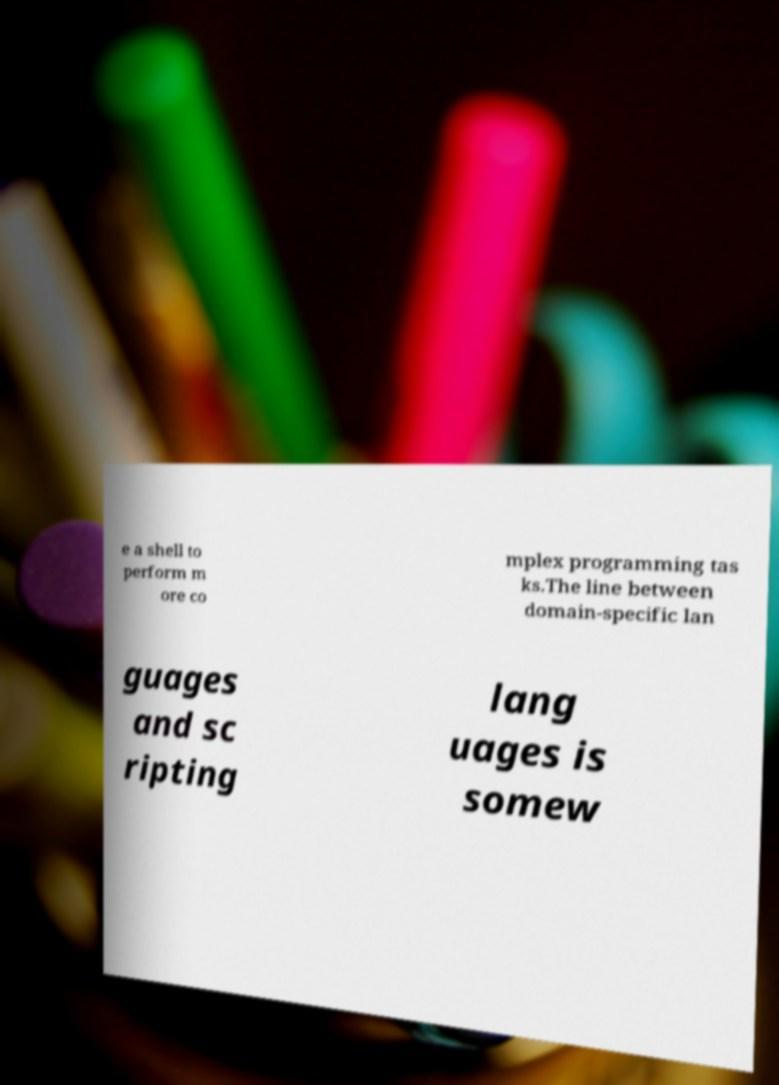Could you extract and type out the text from this image? e a shell to perform m ore co mplex programming tas ks.The line between domain-specific lan guages and sc ripting lang uages is somew 